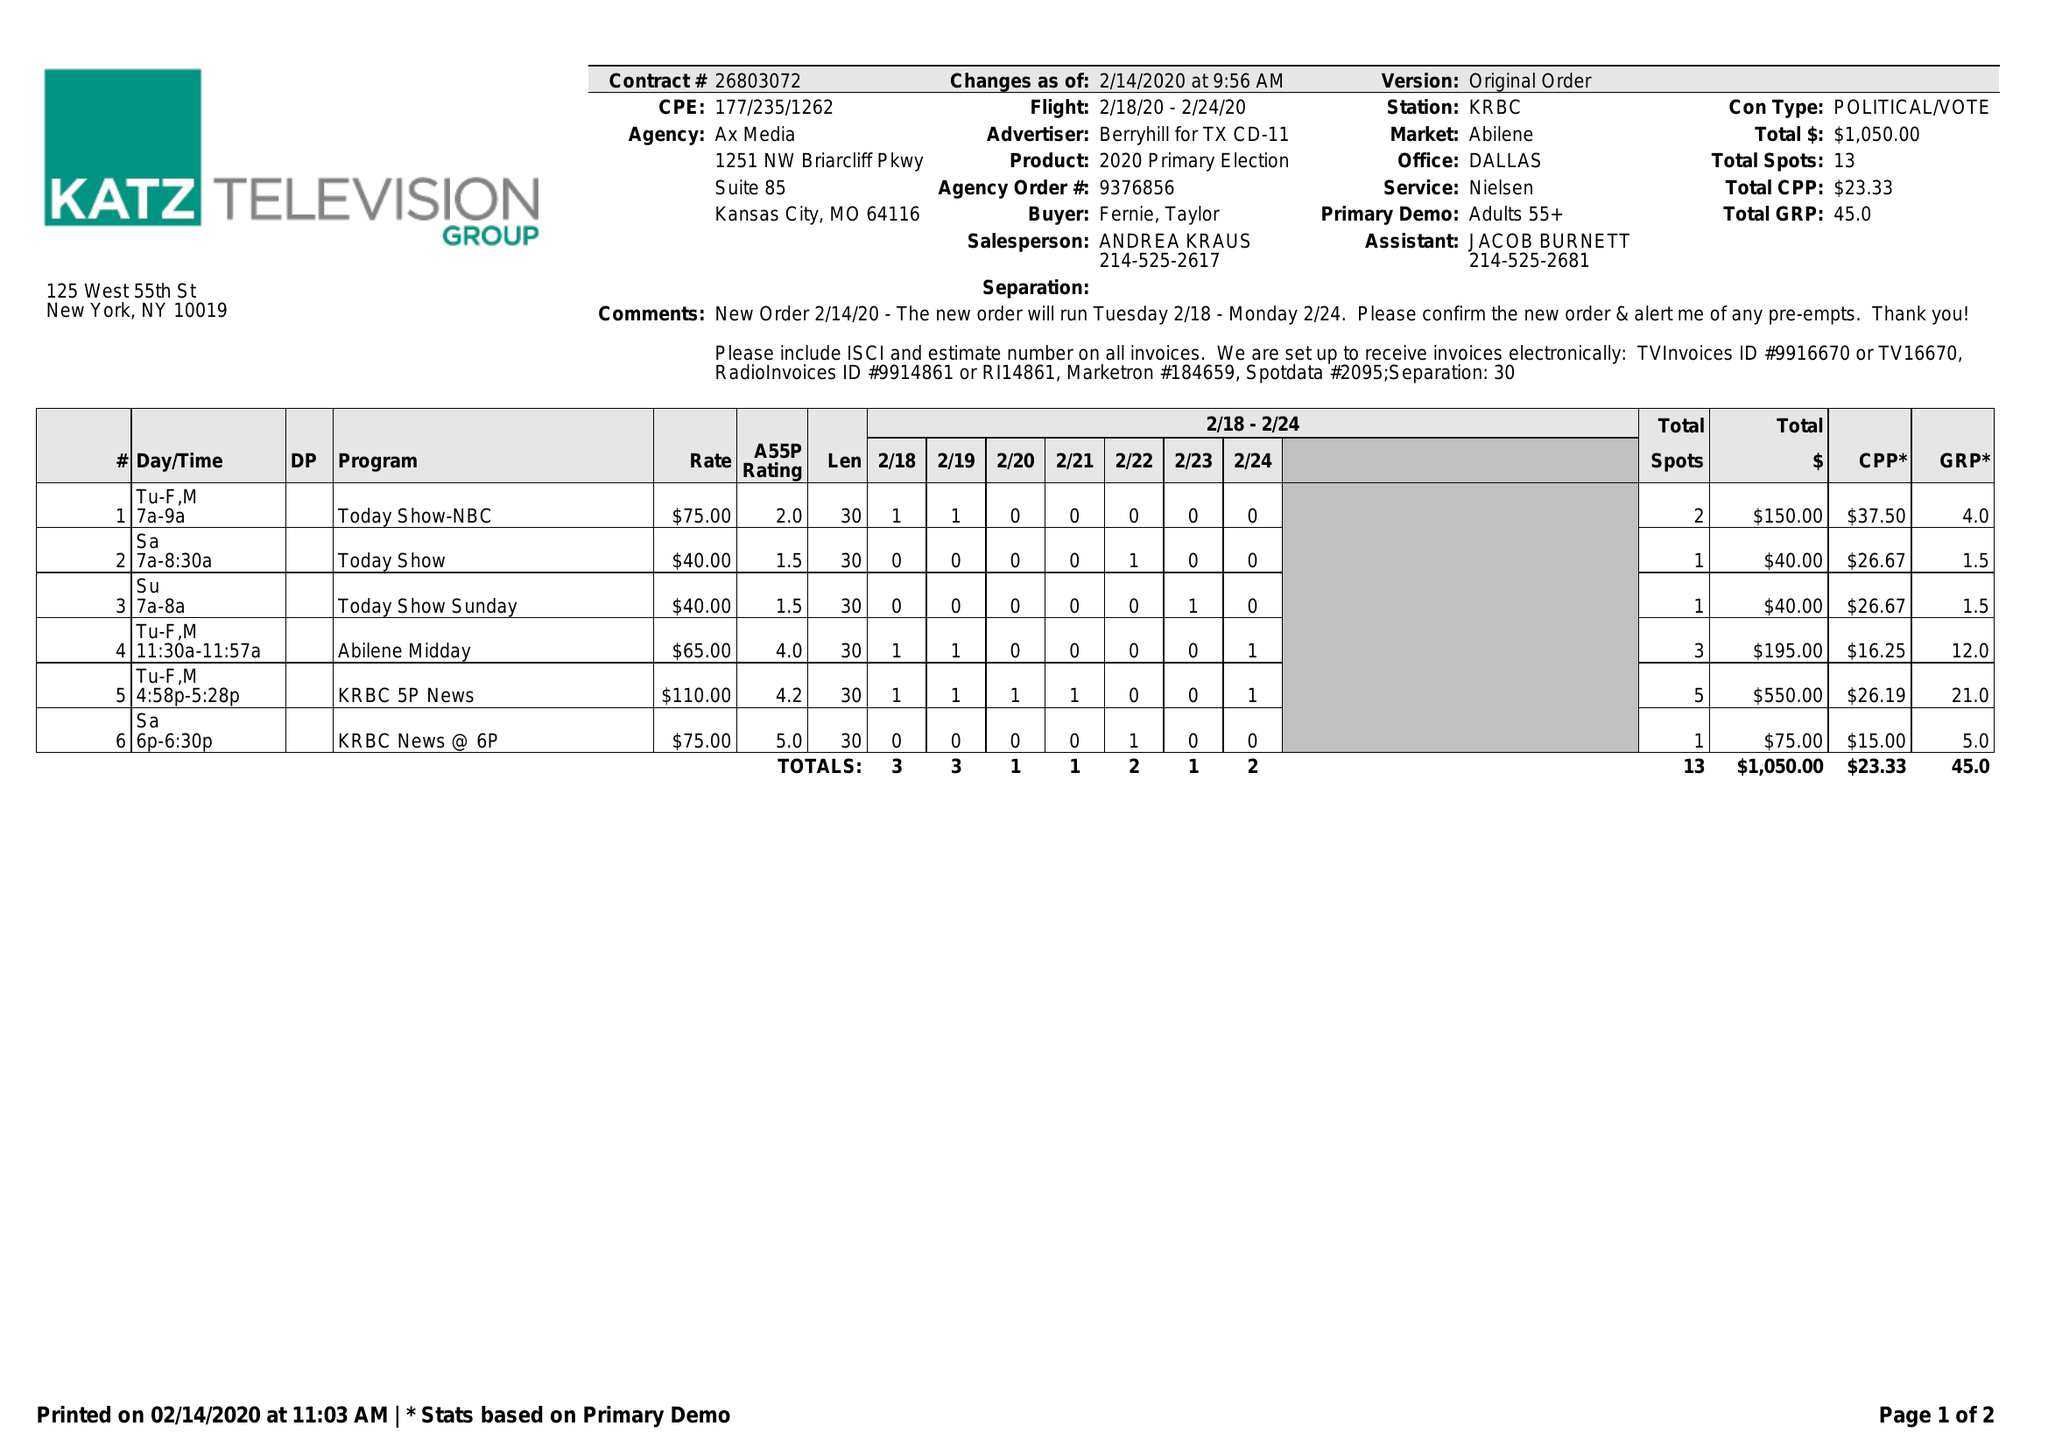What is the value for the flight_from?
Answer the question using a single word or phrase. 02/18/20 